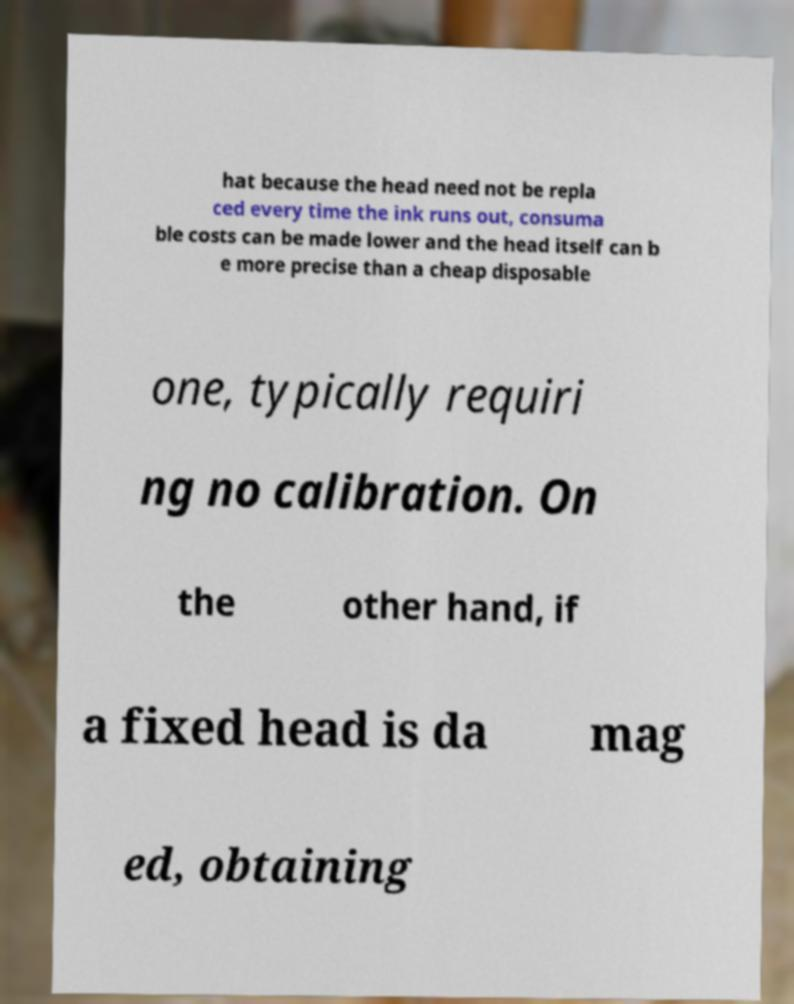Can you read and provide the text displayed in the image?This photo seems to have some interesting text. Can you extract and type it out for me? hat because the head need not be repla ced every time the ink runs out, consuma ble costs can be made lower and the head itself can b e more precise than a cheap disposable one, typically requiri ng no calibration. On the other hand, if a fixed head is da mag ed, obtaining 